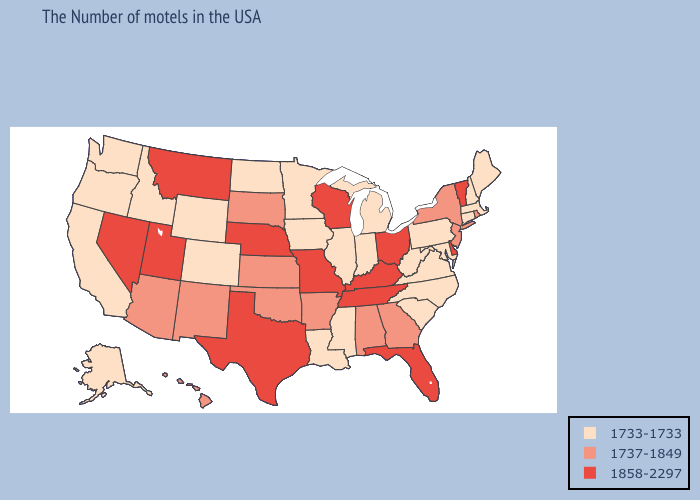What is the lowest value in states that border Virginia?
Answer briefly. 1733-1733. What is the highest value in the South ?
Concise answer only. 1858-2297. Which states have the highest value in the USA?
Give a very brief answer. Vermont, Delaware, Ohio, Florida, Kentucky, Tennessee, Wisconsin, Missouri, Nebraska, Texas, Utah, Montana, Nevada. What is the highest value in states that border Kansas?
Give a very brief answer. 1858-2297. What is the highest value in states that border Nevada?
Concise answer only. 1858-2297. Which states have the lowest value in the Northeast?
Keep it brief. Maine, Massachusetts, New Hampshire, Connecticut, Pennsylvania. Does Montana have the lowest value in the West?
Quick response, please. No. What is the value of Rhode Island?
Keep it brief. 1737-1849. What is the value of New York?
Write a very short answer. 1737-1849. What is the value of Louisiana?
Concise answer only. 1733-1733. Which states hav the highest value in the South?
Give a very brief answer. Delaware, Florida, Kentucky, Tennessee, Texas. Which states have the highest value in the USA?
Give a very brief answer. Vermont, Delaware, Ohio, Florida, Kentucky, Tennessee, Wisconsin, Missouri, Nebraska, Texas, Utah, Montana, Nevada. Among the states that border Vermont , does New Hampshire have the lowest value?
Be succinct. Yes. Among the states that border Delaware , does New Jersey have the highest value?
Write a very short answer. Yes. Does Arkansas have the lowest value in the South?
Keep it brief. No. 